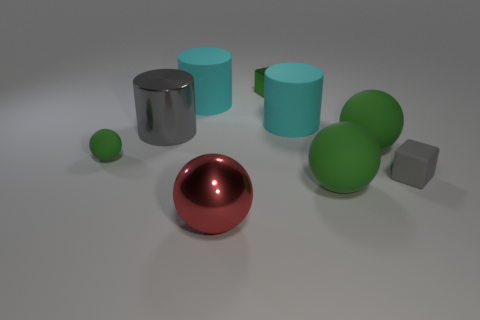Are there fewer big cyan things in front of the small green metallic block than spheres behind the large red metallic object?
Provide a short and direct response. Yes. What color is the other small object that is the same shape as the red thing?
Offer a very short reply. Green. What number of big things are both on the right side of the big gray cylinder and to the left of the large red shiny object?
Offer a very short reply. 1. Is the number of large green spheres in front of the matte cube greater than the number of big red spheres on the left side of the tiny sphere?
Your answer should be compact. Yes. The gray matte cube has what size?
Provide a succinct answer. Small. Are there any tiny gray objects of the same shape as the small green shiny object?
Your response must be concise. Yes. Does the gray metallic thing have the same shape as the large cyan rubber thing to the right of the large red metal object?
Your answer should be very brief. Yes. What size is the matte thing that is left of the small green metallic block and in front of the gray shiny cylinder?
Your answer should be compact. Small. What number of green objects are there?
Your response must be concise. 4. There is a green object that is the same size as the green cube; what is its material?
Your answer should be compact. Rubber. 